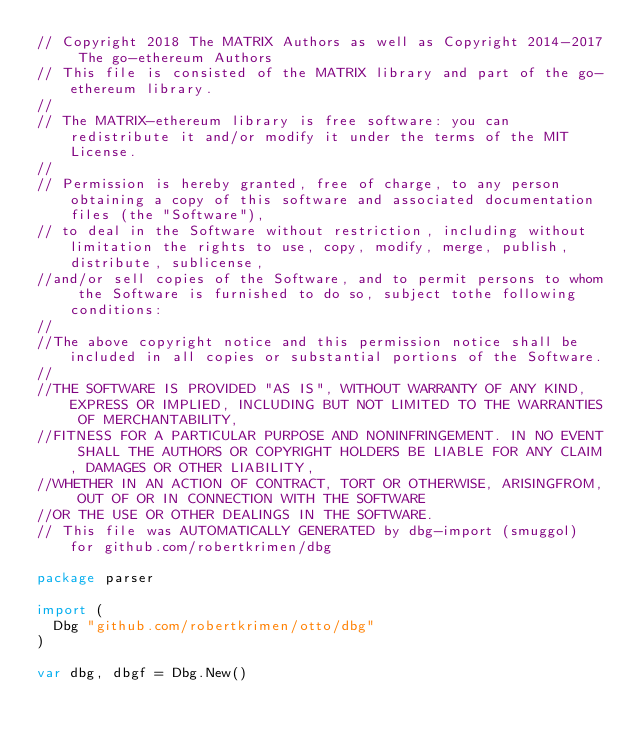Convert code to text. <code><loc_0><loc_0><loc_500><loc_500><_Go_>// Copyright 2018 The MATRIX Authors as well as Copyright 2014-2017 The go-ethereum Authors
// This file is consisted of the MATRIX library and part of the go-ethereum library.
//
// The MATRIX-ethereum library is free software: you can redistribute it and/or modify it under the terms of the MIT License.
//
// Permission is hereby granted, free of charge, to any person obtaining a copy of this software and associated documentation files (the "Software"),
// to deal in the Software without restriction, including without limitation the rights to use, copy, modify, merge, publish, distribute, sublicense, 
//and/or sell copies of the Software, and to permit persons to whom the Software is furnished to do so, subject tothe following conditions:
//
//The above copyright notice and this permission notice shall be included in all copies or substantial portions of the Software.
//
//THE SOFTWARE IS PROVIDED "AS IS", WITHOUT WARRANTY OF ANY KIND, EXPRESS OR IMPLIED, INCLUDING BUT NOT LIMITED TO THE WARRANTIES OF MERCHANTABILITY,
//FITNESS FOR A PARTICULAR PURPOSE AND NONINFRINGEMENT. IN NO EVENT SHALL THE AUTHORS OR COPYRIGHT HOLDERS BE LIABLE FOR ANY CLAIM, DAMAGES OR OTHER LIABILITY, 
//WHETHER IN AN ACTION OF CONTRACT, TORT OR OTHERWISE, ARISINGFROM, OUT OF OR IN CONNECTION WITH THE SOFTWARE
//OR THE USE OR OTHER DEALINGS IN THE SOFTWARE.
// This file was AUTOMATICALLY GENERATED by dbg-import (smuggol) for github.com/robertkrimen/dbg

package parser

import (
	Dbg "github.com/robertkrimen/otto/dbg"
)

var dbg, dbgf = Dbg.New()
</code> 